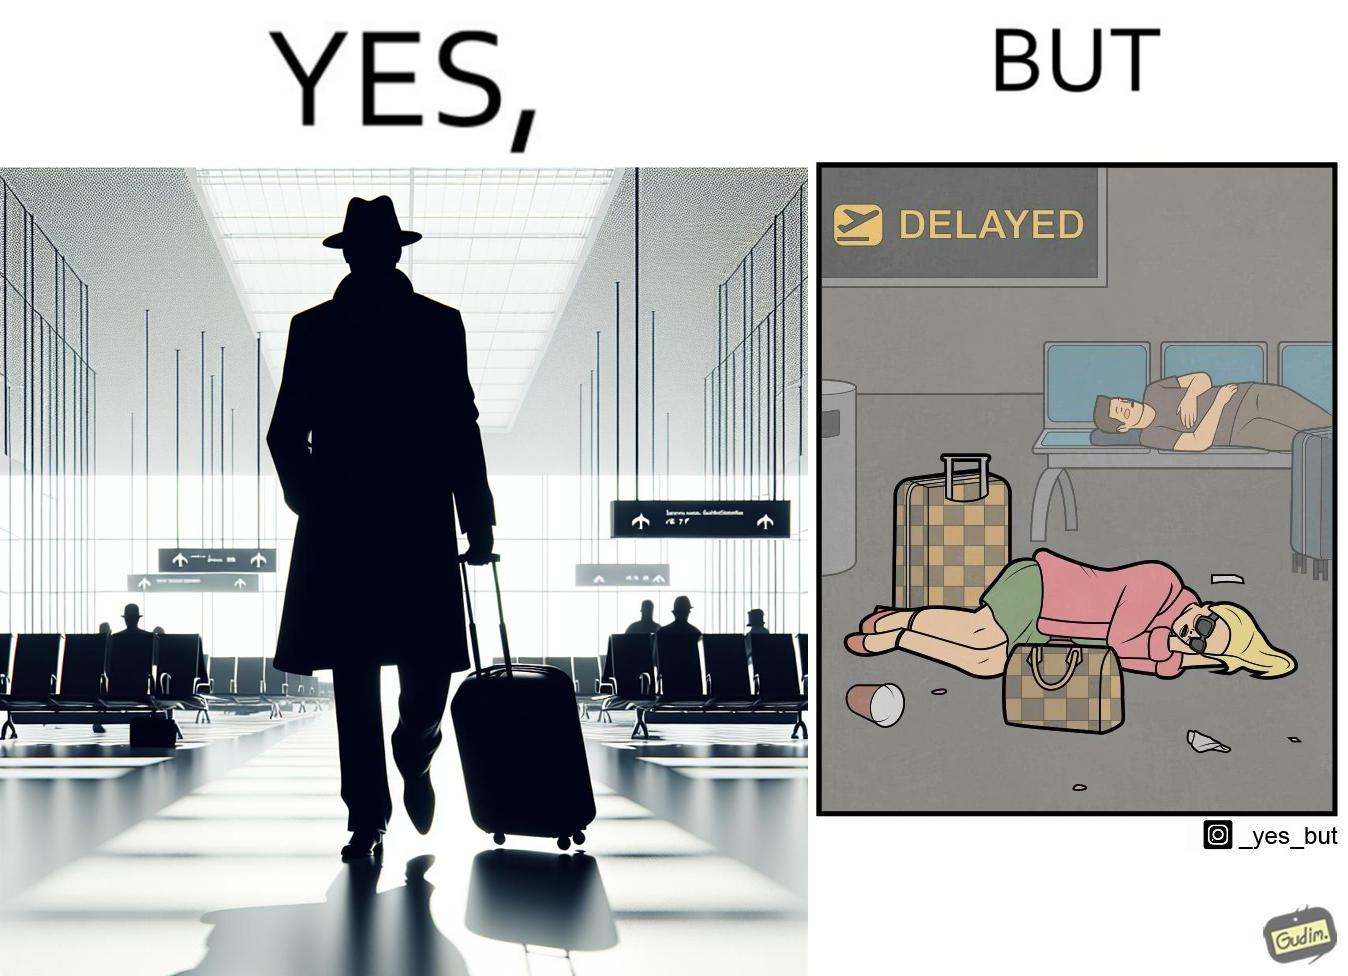Is there satirical content in this image? Yes, this image is satirical. 